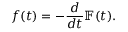Convert formula to latex. <formula><loc_0><loc_0><loc_500><loc_500>f ( t ) = - \frac { d } { d t } \mathbb { F } ( t ) .</formula> 